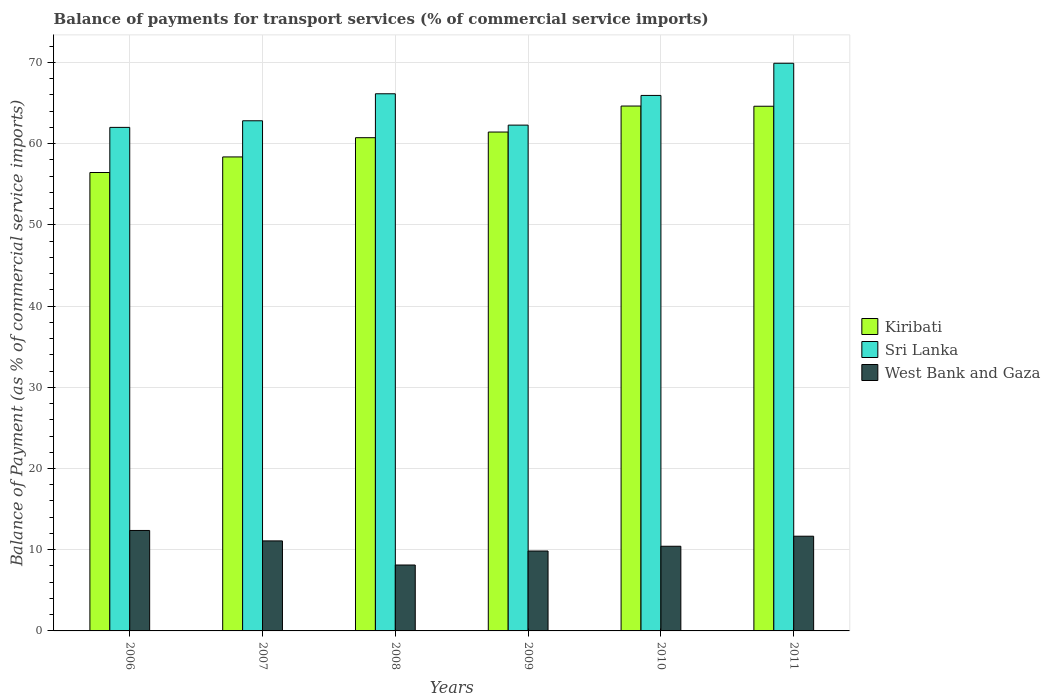How many different coloured bars are there?
Offer a terse response. 3. Are the number of bars on each tick of the X-axis equal?
Offer a very short reply. Yes. How many bars are there on the 2nd tick from the left?
Provide a short and direct response. 3. How many bars are there on the 3rd tick from the right?
Ensure brevity in your answer.  3. In how many cases, is the number of bars for a given year not equal to the number of legend labels?
Ensure brevity in your answer.  0. What is the balance of payments for transport services in Kiribati in 2009?
Your response must be concise. 61.44. Across all years, what is the maximum balance of payments for transport services in Kiribati?
Make the answer very short. 64.64. Across all years, what is the minimum balance of payments for transport services in West Bank and Gaza?
Offer a very short reply. 8.12. In which year was the balance of payments for transport services in West Bank and Gaza minimum?
Your response must be concise. 2008. What is the total balance of payments for transport services in Sri Lanka in the graph?
Provide a succinct answer. 389.12. What is the difference between the balance of payments for transport services in West Bank and Gaza in 2007 and that in 2010?
Make the answer very short. 0.66. What is the difference between the balance of payments for transport services in West Bank and Gaza in 2007 and the balance of payments for transport services in Kiribati in 2010?
Make the answer very short. -53.55. What is the average balance of payments for transport services in Kiribati per year?
Offer a terse response. 61.04. In the year 2009, what is the difference between the balance of payments for transport services in Kiribati and balance of payments for transport services in West Bank and Gaza?
Offer a terse response. 51.59. What is the ratio of the balance of payments for transport services in West Bank and Gaza in 2008 to that in 2009?
Ensure brevity in your answer.  0.82. Is the balance of payments for transport services in Sri Lanka in 2006 less than that in 2008?
Keep it short and to the point. Yes. Is the difference between the balance of payments for transport services in Kiribati in 2008 and 2010 greater than the difference between the balance of payments for transport services in West Bank and Gaza in 2008 and 2010?
Provide a succinct answer. No. What is the difference between the highest and the second highest balance of payments for transport services in Kiribati?
Your answer should be very brief. 0.03. What is the difference between the highest and the lowest balance of payments for transport services in Kiribati?
Provide a succinct answer. 8.19. In how many years, is the balance of payments for transport services in Sri Lanka greater than the average balance of payments for transport services in Sri Lanka taken over all years?
Your answer should be very brief. 3. What does the 3rd bar from the left in 2007 represents?
Offer a very short reply. West Bank and Gaza. What does the 1st bar from the right in 2006 represents?
Your answer should be compact. West Bank and Gaza. How many bars are there?
Your answer should be very brief. 18. Are the values on the major ticks of Y-axis written in scientific E-notation?
Provide a short and direct response. No. Where does the legend appear in the graph?
Give a very brief answer. Center right. How many legend labels are there?
Offer a terse response. 3. How are the legend labels stacked?
Your response must be concise. Vertical. What is the title of the graph?
Give a very brief answer. Balance of payments for transport services (% of commercial service imports). What is the label or title of the X-axis?
Offer a very short reply. Years. What is the label or title of the Y-axis?
Your answer should be compact. Balance of Payment (as % of commercial service imports). What is the Balance of Payment (as % of commercial service imports) of Kiribati in 2006?
Provide a succinct answer. 56.45. What is the Balance of Payment (as % of commercial service imports) of Sri Lanka in 2006?
Provide a succinct answer. 62.01. What is the Balance of Payment (as % of commercial service imports) of West Bank and Gaza in 2006?
Make the answer very short. 12.37. What is the Balance of Payment (as % of commercial service imports) in Kiribati in 2007?
Provide a succinct answer. 58.37. What is the Balance of Payment (as % of commercial service imports) of Sri Lanka in 2007?
Your answer should be compact. 62.82. What is the Balance of Payment (as % of commercial service imports) in West Bank and Gaza in 2007?
Ensure brevity in your answer.  11.09. What is the Balance of Payment (as % of commercial service imports) in Kiribati in 2008?
Your answer should be compact. 60.74. What is the Balance of Payment (as % of commercial service imports) in Sri Lanka in 2008?
Provide a succinct answer. 66.15. What is the Balance of Payment (as % of commercial service imports) of West Bank and Gaza in 2008?
Offer a very short reply. 8.12. What is the Balance of Payment (as % of commercial service imports) in Kiribati in 2009?
Make the answer very short. 61.44. What is the Balance of Payment (as % of commercial service imports) in Sri Lanka in 2009?
Provide a succinct answer. 62.29. What is the Balance of Payment (as % of commercial service imports) in West Bank and Gaza in 2009?
Provide a short and direct response. 9.84. What is the Balance of Payment (as % of commercial service imports) of Kiribati in 2010?
Give a very brief answer. 64.64. What is the Balance of Payment (as % of commercial service imports) of Sri Lanka in 2010?
Your response must be concise. 65.94. What is the Balance of Payment (as % of commercial service imports) of West Bank and Gaza in 2010?
Provide a short and direct response. 10.43. What is the Balance of Payment (as % of commercial service imports) in Kiribati in 2011?
Your answer should be very brief. 64.61. What is the Balance of Payment (as % of commercial service imports) of Sri Lanka in 2011?
Offer a very short reply. 69.91. What is the Balance of Payment (as % of commercial service imports) of West Bank and Gaza in 2011?
Offer a very short reply. 11.66. Across all years, what is the maximum Balance of Payment (as % of commercial service imports) in Kiribati?
Make the answer very short. 64.64. Across all years, what is the maximum Balance of Payment (as % of commercial service imports) in Sri Lanka?
Provide a short and direct response. 69.91. Across all years, what is the maximum Balance of Payment (as % of commercial service imports) in West Bank and Gaza?
Ensure brevity in your answer.  12.37. Across all years, what is the minimum Balance of Payment (as % of commercial service imports) in Kiribati?
Keep it short and to the point. 56.45. Across all years, what is the minimum Balance of Payment (as % of commercial service imports) of Sri Lanka?
Offer a terse response. 62.01. Across all years, what is the minimum Balance of Payment (as % of commercial service imports) of West Bank and Gaza?
Offer a terse response. 8.12. What is the total Balance of Payment (as % of commercial service imports) of Kiribati in the graph?
Make the answer very short. 366.24. What is the total Balance of Payment (as % of commercial service imports) in Sri Lanka in the graph?
Provide a succinct answer. 389.12. What is the total Balance of Payment (as % of commercial service imports) of West Bank and Gaza in the graph?
Offer a very short reply. 63.5. What is the difference between the Balance of Payment (as % of commercial service imports) in Kiribati in 2006 and that in 2007?
Your response must be concise. -1.92. What is the difference between the Balance of Payment (as % of commercial service imports) in Sri Lanka in 2006 and that in 2007?
Provide a short and direct response. -0.82. What is the difference between the Balance of Payment (as % of commercial service imports) of West Bank and Gaza in 2006 and that in 2007?
Offer a very short reply. 1.28. What is the difference between the Balance of Payment (as % of commercial service imports) in Kiribati in 2006 and that in 2008?
Your response must be concise. -4.29. What is the difference between the Balance of Payment (as % of commercial service imports) of Sri Lanka in 2006 and that in 2008?
Your answer should be compact. -4.14. What is the difference between the Balance of Payment (as % of commercial service imports) of West Bank and Gaza in 2006 and that in 2008?
Keep it short and to the point. 4.25. What is the difference between the Balance of Payment (as % of commercial service imports) of Kiribati in 2006 and that in 2009?
Your response must be concise. -4.98. What is the difference between the Balance of Payment (as % of commercial service imports) in Sri Lanka in 2006 and that in 2009?
Offer a terse response. -0.28. What is the difference between the Balance of Payment (as % of commercial service imports) of West Bank and Gaza in 2006 and that in 2009?
Keep it short and to the point. 2.53. What is the difference between the Balance of Payment (as % of commercial service imports) in Kiribati in 2006 and that in 2010?
Your response must be concise. -8.19. What is the difference between the Balance of Payment (as % of commercial service imports) in Sri Lanka in 2006 and that in 2010?
Keep it short and to the point. -3.94. What is the difference between the Balance of Payment (as % of commercial service imports) of West Bank and Gaza in 2006 and that in 2010?
Provide a succinct answer. 1.94. What is the difference between the Balance of Payment (as % of commercial service imports) of Kiribati in 2006 and that in 2011?
Provide a short and direct response. -8.16. What is the difference between the Balance of Payment (as % of commercial service imports) of Sri Lanka in 2006 and that in 2011?
Keep it short and to the point. -7.9. What is the difference between the Balance of Payment (as % of commercial service imports) in West Bank and Gaza in 2006 and that in 2011?
Provide a succinct answer. 0.71. What is the difference between the Balance of Payment (as % of commercial service imports) of Kiribati in 2007 and that in 2008?
Provide a short and direct response. -2.37. What is the difference between the Balance of Payment (as % of commercial service imports) of Sri Lanka in 2007 and that in 2008?
Your answer should be compact. -3.32. What is the difference between the Balance of Payment (as % of commercial service imports) in West Bank and Gaza in 2007 and that in 2008?
Offer a very short reply. 2.97. What is the difference between the Balance of Payment (as % of commercial service imports) in Kiribati in 2007 and that in 2009?
Provide a succinct answer. -3.07. What is the difference between the Balance of Payment (as % of commercial service imports) in Sri Lanka in 2007 and that in 2009?
Offer a terse response. 0.54. What is the difference between the Balance of Payment (as % of commercial service imports) of West Bank and Gaza in 2007 and that in 2009?
Provide a succinct answer. 1.24. What is the difference between the Balance of Payment (as % of commercial service imports) of Kiribati in 2007 and that in 2010?
Make the answer very short. -6.27. What is the difference between the Balance of Payment (as % of commercial service imports) of Sri Lanka in 2007 and that in 2010?
Ensure brevity in your answer.  -3.12. What is the difference between the Balance of Payment (as % of commercial service imports) in West Bank and Gaza in 2007 and that in 2010?
Keep it short and to the point. 0.66. What is the difference between the Balance of Payment (as % of commercial service imports) in Kiribati in 2007 and that in 2011?
Offer a terse response. -6.24. What is the difference between the Balance of Payment (as % of commercial service imports) of Sri Lanka in 2007 and that in 2011?
Ensure brevity in your answer.  -7.08. What is the difference between the Balance of Payment (as % of commercial service imports) of West Bank and Gaza in 2007 and that in 2011?
Your answer should be very brief. -0.58. What is the difference between the Balance of Payment (as % of commercial service imports) in Kiribati in 2008 and that in 2009?
Your answer should be compact. -0.7. What is the difference between the Balance of Payment (as % of commercial service imports) in Sri Lanka in 2008 and that in 2009?
Offer a very short reply. 3.86. What is the difference between the Balance of Payment (as % of commercial service imports) in West Bank and Gaza in 2008 and that in 2009?
Provide a succinct answer. -1.72. What is the difference between the Balance of Payment (as % of commercial service imports) of Kiribati in 2008 and that in 2010?
Your answer should be compact. -3.9. What is the difference between the Balance of Payment (as % of commercial service imports) of Sri Lanka in 2008 and that in 2010?
Make the answer very short. 0.2. What is the difference between the Balance of Payment (as % of commercial service imports) in West Bank and Gaza in 2008 and that in 2010?
Your answer should be compact. -2.31. What is the difference between the Balance of Payment (as % of commercial service imports) of Kiribati in 2008 and that in 2011?
Your answer should be very brief. -3.87. What is the difference between the Balance of Payment (as % of commercial service imports) in Sri Lanka in 2008 and that in 2011?
Your response must be concise. -3.76. What is the difference between the Balance of Payment (as % of commercial service imports) of West Bank and Gaza in 2008 and that in 2011?
Provide a succinct answer. -3.55. What is the difference between the Balance of Payment (as % of commercial service imports) in Kiribati in 2009 and that in 2010?
Provide a short and direct response. -3.2. What is the difference between the Balance of Payment (as % of commercial service imports) of Sri Lanka in 2009 and that in 2010?
Offer a very short reply. -3.65. What is the difference between the Balance of Payment (as % of commercial service imports) of West Bank and Gaza in 2009 and that in 2010?
Offer a very short reply. -0.58. What is the difference between the Balance of Payment (as % of commercial service imports) of Kiribati in 2009 and that in 2011?
Your answer should be very brief. -3.18. What is the difference between the Balance of Payment (as % of commercial service imports) in Sri Lanka in 2009 and that in 2011?
Provide a succinct answer. -7.62. What is the difference between the Balance of Payment (as % of commercial service imports) in West Bank and Gaza in 2009 and that in 2011?
Make the answer very short. -1.82. What is the difference between the Balance of Payment (as % of commercial service imports) in Kiribati in 2010 and that in 2011?
Keep it short and to the point. 0.03. What is the difference between the Balance of Payment (as % of commercial service imports) in Sri Lanka in 2010 and that in 2011?
Ensure brevity in your answer.  -3.96. What is the difference between the Balance of Payment (as % of commercial service imports) of West Bank and Gaza in 2010 and that in 2011?
Give a very brief answer. -1.24. What is the difference between the Balance of Payment (as % of commercial service imports) of Kiribati in 2006 and the Balance of Payment (as % of commercial service imports) of Sri Lanka in 2007?
Offer a terse response. -6.37. What is the difference between the Balance of Payment (as % of commercial service imports) of Kiribati in 2006 and the Balance of Payment (as % of commercial service imports) of West Bank and Gaza in 2007?
Give a very brief answer. 45.37. What is the difference between the Balance of Payment (as % of commercial service imports) of Sri Lanka in 2006 and the Balance of Payment (as % of commercial service imports) of West Bank and Gaza in 2007?
Ensure brevity in your answer.  50.92. What is the difference between the Balance of Payment (as % of commercial service imports) of Kiribati in 2006 and the Balance of Payment (as % of commercial service imports) of Sri Lanka in 2008?
Offer a terse response. -9.7. What is the difference between the Balance of Payment (as % of commercial service imports) of Kiribati in 2006 and the Balance of Payment (as % of commercial service imports) of West Bank and Gaza in 2008?
Offer a very short reply. 48.33. What is the difference between the Balance of Payment (as % of commercial service imports) of Sri Lanka in 2006 and the Balance of Payment (as % of commercial service imports) of West Bank and Gaza in 2008?
Make the answer very short. 53.89. What is the difference between the Balance of Payment (as % of commercial service imports) of Kiribati in 2006 and the Balance of Payment (as % of commercial service imports) of Sri Lanka in 2009?
Your response must be concise. -5.84. What is the difference between the Balance of Payment (as % of commercial service imports) in Kiribati in 2006 and the Balance of Payment (as % of commercial service imports) in West Bank and Gaza in 2009?
Give a very brief answer. 46.61. What is the difference between the Balance of Payment (as % of commercial service imports) of Sri Lanka in 2006 and the Balance of Payment (as % of commercial service imports) of West Bank and Gaza in 2009?
Make the answer very short. 52.17. What is the difference between the Balance of Payment (as % of commercial service imports) in Kiribati in 2006 and the Balance of Payment (as % of commercial service imports) in Sri Lanka in 2010?
Provide a succinct answer. -9.49. What is the difference between the Balance of Payment (as % of commercial service imports) of Kiribati in 2006 and the Balance of Payment (as % of commercial service imports) of West Bank and Gaza in 2010?
Give a very brief answer. 46.03. What is the difference between the Balance of Payment (as % of commercial service imports) of Sri Lanka in 2006 and the Balance of Payment (as % of commercial service imports) of West Bank and Gaza in 2010?
Your response must be concise. 51.58. What is the difference between the Balance of Payment (as % of commercial service imports) of Kiribati in 2006 and the Balance of Payment (as % of commercial service imports) of Sri Lanka in 2011?
Ensure brevity in your answer.  -13.45. What is the difference between the Balance of Payment (as % of commercial service imports) of Kiribati in 2006 and the Balance of Payment (as % of commercial service imports) of West Bank and Gaza in 2011?
Ensure brevity in your answer.  44.79. What is the difference between the Balance of Payment (as % of commercial service imports) of Sri Lanka in 2006 and the Balance of Payment (as % of commercial service imports) of West Bank and Gaza in 2011?
Your response must be concise. 50.34. What is the difference between the Balance of Payment (as % of commercial service imports) of Kiribati in 2007 and the Balance of Payment (as % of commercial service imports) of Sri Lanka in 2008?
Ensure brevity in your answer.  -7.78. What is the difference between the Balance of Payment (as % of commercial service imports) of Kiribati in 2007 and the Balance of Payment (as % of commercial service imports) of West Bank and Gaza in 2008?
Provide a short and direct response. 50.25. What is the difference between the Balance of Payment (as % of commercial service imports) in Sri Lanka in 2007 and the Balance of Payment (as % of commercial service imports) in West Bank and Gaza in 2008?
Provide a succinct answer. 54.71. What is the difference between the Balance of Payment (as % of commercial service imports) of Kiribati in 2007 and the Balance of Payment (as % of commercial service imports) of Sri Lanka in 2009?
Ensure brevity in your answer.  -3.92. What is the difference between the Balance of Payment (as % of commercial service imports) of Kiribati in 2007 and the Balance of Payment (as % of commercial service imports) of West Bank and Gaza in 2009?
Keep it short and to the point. 48.53. What is the difference between the Balance of Payment (as % of commercial service imports) in Sri Lanka in 2007 and the Balance of Payment (as % of commercial service imports) in West Bank and Gaza in 2009?
Keep it short and to the point. 52.98. What is the difference between the Balance of Payment (as % of commercial service imports) of Kiribati in 2007 and the Balance of Payment (as % of commercial service imports) of Sri Lanka in 2010?
Offer a very short reply. -7.57. What is the difference between the Balance of Payment (as % of commercial service imports) of Kiribati in 2007 and the Balance of Payment (as % of commercial service imports) of West Bank and Gaza in 2010?
Ensure brevity in your answer.  47.94. What is the difference between the Balance of Payment (as % of commercial service imports) in Sri Lanka in 2007 and the Balance of Payment (as % of commercial service imports) in West Bank and Gaza in 2010?
Provide a short and direct response. 52.4. What is the difference between the Balance of Payment (as % of commercial service imports) in Kiribati in 2007 and the Balance of Payment (as % of commercial service imports) in Sri Lanka in 2011?
Keep it short and to the point. -11.54. What is the difference between the Balance of Payment (as % of commercial service imports) in Kiribati in 2007 and the Balance of Payment (as % of commercial service imports) in West Bank and Gaza in 2011?
Provide a succinct answer. 46.71. What is the difference between the Balance of Payment (as % of commercial service imports) of Sri Lanka in 2007 and the Balance of Payment (as % of commercial service imports) of West Bank and Gaza in 2011?
Offer a terse response. 51.16. What is the difference between the Balance of Payment (as % of commercial service imports) of Kiribati in 2008 and the Balance of Payment (as % of commercial service imports) of Sri Lanka in 2009?
Your answer should be compact. -1.55. What is the difference between the Balance of Payment (as % of commercial service imports) of Kiribati in 2008 and the Balance of Payment (as % of commercial service imports) of West Bank and Gaza in 2009?
Your answer should be compact. 50.9. What is the difference between the Balance of Payment (as % of commercial service imports) in Sri Lanka in 2008 and the Balance of Payment (as % of commercial service imports) in West Bank and Gaza in 2009?
Give a very brief answer. 56.31. What is the difference between the Balance of Payment (as % of commercial service imports) of Kiribati in 2008 and the Balance of Payment (as % of commercial service imports) of Sri Lanka in 2010?
Your answer should be very brief. -5.2. What is the difference between the Balance of Payment (as % of commercial service imports) in Kiribati in 2008 and the Balance of Payment (as % of commercial service imports) in West Bank and Gaza in 2010?
Your answer should be compact. 50.31. What is the difference between the Balance of Payment (as % of commercial service imports) in Sri Lanka in 2008 and the Balance of Payment (as % of commercial service imports) in West Bank and Gaza in 2010?
Offer a very short reply. 55.72. What is the difference between the Balance of Payment (as % of commercial service imports) in Kiribati in 2008 and the Balance of Payment (as % of commercial service imports) in Sri Lanka in 2011?
Offer a very short reply. -9.17. What is the difference between the Balance of Payment (as % of commercial service imports) of Kiribati in 2008 and the Balance of Payment (as % of commercial service imports) of West Bank and Gaza in 2011?
Your answer should be very brief. 49.07. What is the difference between the Balance of Payment (as % of commercial service imports) of Sri Lanka in 2008 and the Balance of Payment (as % of commercial service imports) of West Bank and Gaza in 2011?
Offer a very short reply. 54.48. What is the difference between the Balance of Payment (as % of commercial service imports) of Kiribati in 2009 and the Balance of Payment (as % of commercial service imports) of Sri Lanka in 2010?
Offer a very short reply. -4.51. What is the difference between the Balance of Payment (as % of commercial service imports) of Kiribati in 2009 and the Balance of Payment (as % of commercial service imports) of West Bank and Gaza in 2010?
Your answer should be very brief. 51.01. What is the difference between the Balance of Payment (as % of commercial service imports) of Sri Lanka in 2009 and the Balance of Payment (as % of commercial service imports) of West Bank and Gaza in 2010?
Ensure brevity in your answer.  51.86. What is the difference between the Balance of Payment (as % of commercial service imports) of Kiribati in 2009 and the Balance of Payment (as % of commercial service imports) of Sri Lanka in 2011?
Provide a short and direct response. -8.47. What is the difference between the Balance of Payment (as % of commercial service imports) in Kiribati in 2009 and the Balance of Payment (as % of commercial service imports) in West Bank and Gaza in 2011?
Ensure brevity in your answer.  49.77. What is the difference between the Balance of Payment (as % of commercial service imports) in Sri Lanka in 2009 and the Balance of Payment (as % of commercial service imports) in West Bank and Gaza in 2011?
Your answer should be compact. 50.62. What is the difference between the Balance of Payment (as % of commercial service imports) in Kiribati in 2010 and the Balance of Payment (as % of commercial service imports) in Sri Lanka in 2011?
Your answer should be very brief. -5.27. What is the difference between the Balance of Payment (as % of commercial service imports) in Kiribati in 2010 and the Balance of Payment (as % of commercial service imports) in West Bank and Gaza in 2011?
Make the answer very short. 52.97. What is the difference between the Balance of Payment (as % of commercial service imports) of Sri Lanka in 2010 and the Balance of Payment (as % of commercial service imports) of West Bank and Gaza in 2011?
Keep it short and to the point. 54.28. What is the average Balance of Payment (as % of commercial service imports) of Kiribati per year?
Make the answer very short. 61.04. What is the average Balance of Payment (as % of commercial service imports) in Sri Lanka per year?
Offer a very short reply. 64.85. What is the average Balance of Payment (as % of commercial service imports) of West Bank and Gaza per year?
Offer a terse response. 10.58. In the year 2006, what is the difference between the Balance of Payment (as % of commercial service imports) of Kiribati and Balance of Payment (as % of commercial service imports) of Sri Lanka?
Your response must be concise. -5.56. In the year 2006, what is the difference between the Balance of Payment (as % of commercial service imports) in Kiribati and Balance of Payment (as % of commercial service imports) in West Bank and Gaza?
Keep it short and to the point. 44.08. In the year 2006, what is the difference between the Balance of Payment (as % of commercial service imports) in Sri Lanka and Balance of Payment (as % of commercial service imports) in West Bank and Gaza?
Offer a very short reply. 49.64. In the year 2007, what is the difference between the Balance of Payment (as % of commercial service imports) in Kiribati and Balance of Payment (as % of commercial service imports) in Sri Lanka?
Your answer should be very brief. -4.45. In the year 2007, what is the difference between the Balance of Payment (as % of commercial service imports) of Kiribati and Balance of Payment (as % of commercial service imports) of West Bank and Gaza?
Offer a very short reply. 47.28. In the year 2007, what is the difference between the Balance of Payment (as % of commercial service imports) of Sri Lanka and Balance of Payment (as % of commercial service imports) of West Bank and Gaza?
Keep it short and to the point. 51.74. In the year 2008, what is the difference between the Balance of Payment (as % of commercial service imports) of Kiribati and Balance of Payment (as % of commercial service imports) of Sri Lanka?
Offer a terse response. -5.41. In the year 2008, what is the difference between the Balance of Payment (as % of commercial service imports) in Kiribati and Balance of Payment (as % of commercial service imports) in West Bank and Gaza?
Offer a very short reply. 52.62. In the year 2008, what is the difference between the Balance of Payment (as % of commercial service imports) in Sri Lanka and Balance of Payment (as % of commercial service imports) in West Bank and Gaza?
Keep it short and to the point. 58.03. In the year 2009, what is the difference between the Balance of Payment (as % of commercial service imports) in Kiribati and Balance of Payment (as % of commercial service imports) in Sri Lanka?
Give a very brief answer. -0.85. In the year 2009, what is the difference between the Balance of Payment (as % of commercial service imports) in Kiribati and Balance of Payment (as % of commercial service imports) in West Bank and Gaza?
Ensure brevity in your answer.  51.59. In the year 2009, what is the difference between the Balance of Payment (as % of commercial service imports) of Sri Lanka and Balance of Payment (as % of commercial service imports) of West Bank and Gaza?
Make the answer very short. 52.45. In the year 2010, what is the difference between the Balance of Payment (as % of commercial service imports) of Kiribati and Balance of Payment (as % of commercial service imports) of Sri Lanka?
Keep it short and to the point. -1.31. In the year 2010, what is the difference between the Balance of Payment (as % of commercial service imports) in Kiribati and Balance of Payment (as % of commercial service imports) in West Bank and Gaza?
Provide a short and direct response. 54.21. In the year 2010, what is the difference between the Balance of Payment (as % of commercial service imports) in Sri Lanka and Balance of Payment (as % of commercial service imports) in West Bank and Gaza?
Your response must be concise. 55.52. In the year 2011, what is the difference between the Balance of Payment (as % of commercial service imports) of Kiribati and Balance of Payment (as % of commercial service imports) of Sri Lanka?
Offer a very short reply. -5.29. In the year 2011, what is the difference between the Balance of Payment (as % of commercial service imports) of Kiribati and Balance of Payment (as % of commercial service imports) of West Bank and Gaza?
Keep it short and to the point. 52.95. In the year 2011, what is the difference between the Balance of Payment (as % of commercial service imports) in Sri Lanka and Balance of Payment (as % of commercial service imports) in West Bank and Gaza?
Offer a terse response. 58.24. What is the ratio of the Balance of Payment (as % of commercial service imports) in Kiribati in 2006 to that in 2007?
Ensure brevity in your answer.  0.97. What is the ratio of the Balance of Payment (as % of commercial service imports) in West Bank and Gaza in 2006 to that in 2007?
Provide a succinct answer. 1.12. What is the ratio of the Balance of Payment (as % of commercial service imports) in Kiribati in 2006 to that in 2008?
Your answer should be very brief. 0.93. What is the ratio of the Balance of Payment (as % of commercial service imports) in Sri Lanka in 2006 to that in 2008?
Make the answer very short. 0.94. What is the ratio of the Balance of Payment (as % of commercial service imports) of West Bank and Gaza in 2006 to that in 2008?
Provide a short and direct response. 1.52. What is the ratio of the Balance of Payment (as % of commercial service imports) in Kiribati in 2006 to that in 2009?
Give a very brief answer. 0.92. What is the ratio of the Balance of Payment (as % of commercial service imports) in West Bank and Gaza in 2006 to that in 2009?
Offer a very short reply. 1.26. What is the ratio of the Balance of Payment (as % of commercial service imports) of Kiribati in 2006 to that in 2010?
Your response must be concise. 0.87. What is the ratio of the Balance of Payment (as % of commercial service imports) in Sri Lanka in 2006 to that in 2010?
Provide a short and direct response. 0.94. What is the ratio of the Balance of Payment (as % of commercial service imports) in West Bank and Gaza in 2006 to that in 2010?
Give a very brief answer. 1.19. What is the ratio of the Balance of Payment (as % of commercial service imports) in Kiribati in 2006 to that in 2011?
Provide a succinct answer. 0.87. What is the ratio of the Balance of Payment (as % of commercial service imports) in Sri Lanka in 2006 to that in 2011?
Offer a very short reply. 0.89. What is the ratio of the Balance of Payment (as % of commercial service imports) in West Bank and Gaza in 2006 to that in 2011?
Ensure brevity in your answer.  1.06. What is the ratio of the Balance of Payment (as % of commercial service imports) in Sri Lanka in 2007 to that in 2008?
Make the answer very short. 0.95. What is the ratio of the Balance of Payment (as % of commercial service imports) of West Bank and Gaza in 2007 to that in 2008?
Your response must be concise. 1.37. What is the ratio of the Balance of Payment (as % of commercial service imports) in Kiribati in 2007 to that in 2009?
Give a very brief answer. 0.95. What is the ratio of the Balance of Payment (as % of commercial service imports) in Sri Lanka in 2007 to that in 2009?
Your response must be concise. 1.01. What is the ratio of the Balance of Payment (as % of commercial service imports) of West Bank and Gaza in 2007 to that in 2009?
Provide a succinct answer. 1.13. What is the ratio of the Balance of Payment (as % of commercial service imports) in Kiribati in 2007 to that in 2010?
Provide a short and direct response. 0.9. What is the ratio of the Balance of Payment (as % of commercial service imports) in Sri Lanka in 2007 to that in 2010?
Provide a short and direct response. 0.95. What is the ratio of the Balance of Payment (as % of commercial service imports) in West Bank and Gaza in 2007 to that in 2010?
Provide a short and direct response. 1.06. What is the ratio of the Balance of Payment (as % of commercial service imports) of Kiribati in 2007 to that in 2011?
Keep it short and to the point. 0.9. What is the ratio of the Balance of Payment (as % of commercial service imports) in Sri Lanka in 2007 to that in 2011?
Offer a terse response. 0.9. What is the ratio of the Balance of Payment (as % of commercial service imports) in West Bank and Gaza in 2007 to that in 2011?
Provide a succinct answer. 0.95. What is the ratio of the Balance of Payment (as % of commercial service imports) of Kiribati in 2008 to that in 2009?
Offer a very short reply. 0.99. What is the ratio of the Balance of Payment (as % of commercial service imports) of Sri Lanka in 2008 to that in 2009?
Your answer should be compact. 1.06. What is the ratio of the Balance of Payment (as % of commercial service imports) of West Bank and Gaza in 2008 to that in 2009?
Give a very brief answer. 0.82. What is the ratio of the Balance of Payment (as % of commercial service imports) of Kiribati in 2008 to that in 2010?
Give a very brief answer. 0.94. What is the ratio of the Balance of Payment (as % of commercial service imports) in West Bank and Gaza in 2008 to that in 2010?
Make the answer very short. 0.78. What is the ratio of the Balance of Payment (as % of commercial service imports) of Kiribati in 2008 to that in 2011?
Your answer should be very brief. 0.94. What is the ratio of the Balance of Payment (as % of commercial service imports) in Sri Lanka in 2008 to that in 2011?
Your answer should be compact. 0.95. What is the ratio of the Balance of Payment (as % of commercial service imports) of West Bank and Gaza in 2008 to that in 2011?
Offer a terse response. 0.7. What is the ratio of the Balance of Payment (as % of commercial service imports) of Kiribati in 2009 to that in 2010?
Provide a succinct answer. 0.95. What is the ratio of the Balance of Payment (as % of commercial service imports) in Sri Lanka in 2009 to that in 2010?
Your response must be concise. 0.94. What is the ratio of the Balance of Payment (as % of commercial service imports) of West Bank and Gaza in 2009 to that in 2010?
Provide a short and direct response. 0.94. What is the ratio of the Balance of Payment (as % of commercial service imports) of Kiribati in 2009 to that in 2011?
Offer a terse response. 0.95. What is the ratio of the Balance of Payment (as % of commercial service imports) of Sri Lanka in 2009 to that in 2011?
Provide a succinct answer. 0.89. What is the ratio of the Balance of Payment (as % of commercial service imports) in West Bank and Gaza in 2009 to that in 2011?
Offer a very short reply. 0.84. What is the ratio of the Balance of Payment (as % of commercial service imports) in Sri Lanka in 2010 to that in 2011?
Offer a terse response. 0.94. What is the ratio of the Balance of Payment (as % of commercial service imports) of West Bank and Gaza in 2010 to that in 2011?
Your answer should be compact. 0.89. What is the difference between the highest and the second highest Balance of Payment (as % of commercial service imports) in Kiribati?
Provide a short and direct response. 0.03. What is the difference between the highest and the second highest Balance of Payment (as % of commercial service imports) in Sri Lanka?
Offer a terse response. 3.76. What is the difference between the highest and the second highest Balance of Payment (as % of commercial service imports) of West Bank and Gaza?
Make the answer very short. 0.71. What is the difference between the highest and the lowest Balance of Payment (as % of commercial service imports) in Kiribati?
Keep it short and to the point. 8.19. What is the difference between the highest and the lowest Balance of Payment (as % of commercial service imports) in Sri Lanka?
Offer a very short reply. 7.9. What is the difference between the highest and the lowest Balance of Payment (as % of commercial service imports) in West Bank and Gaza?
Your answer should be very brief. 4.25. 